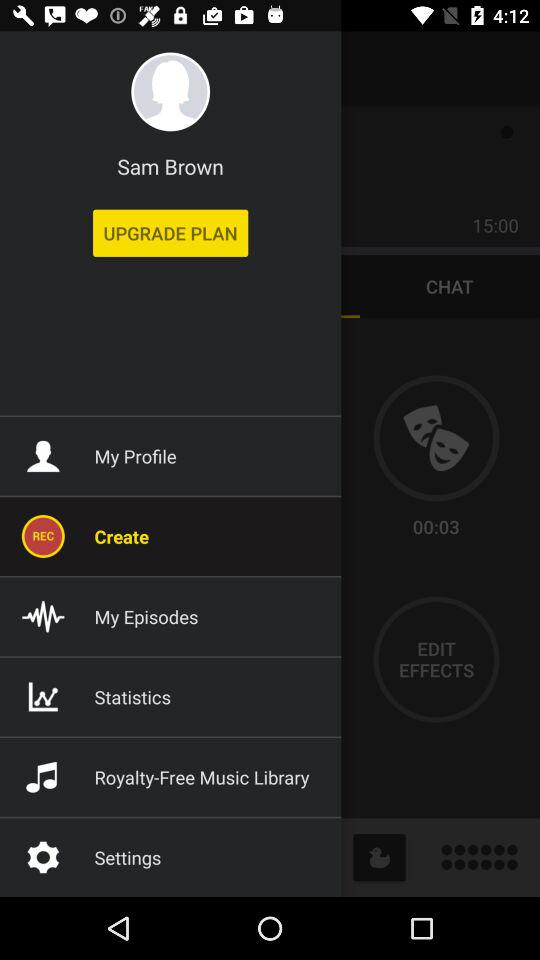Which item is currently selected? The currently selected item is "Create". 